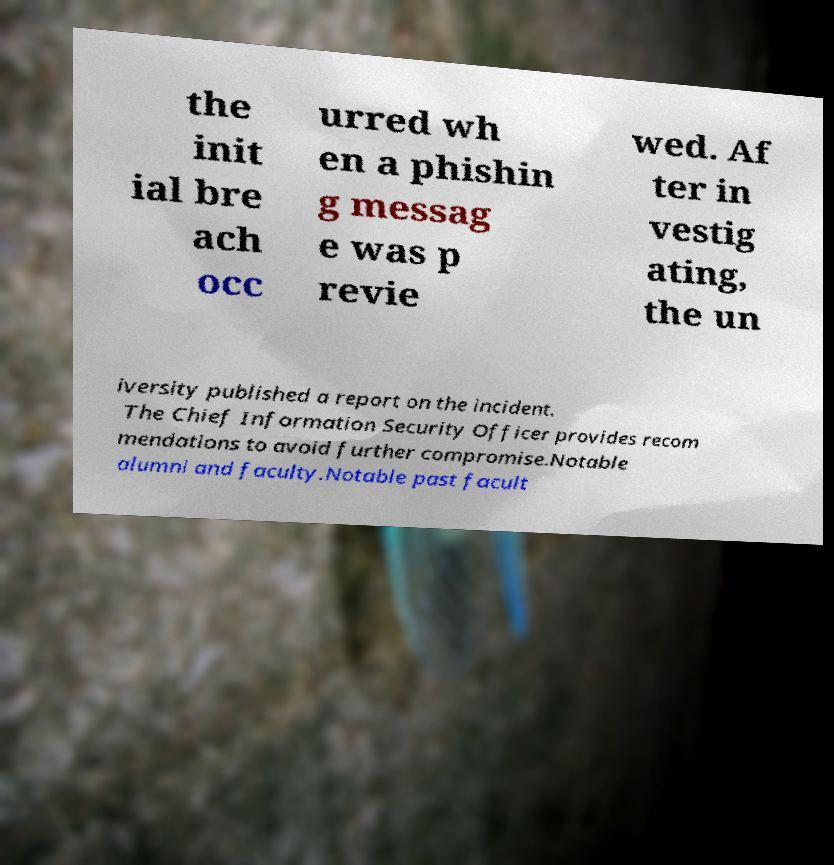For documentation purposes, I need the text within this image transcribed. Could you provide that? the init ial bre ach occ urred wh en a phishin g messag e was p revie wed. Af ter in vestig ating, the un iversity published a report on the incident. The Chief Information Security Officer provides recom mendations to avoid further compromise.Notable alumni and faculty.Notable past facult 